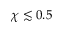<formula> <loc_0><loc_0><loc_500><loc_500>\chi \lesssim 0 . 5</formula> 